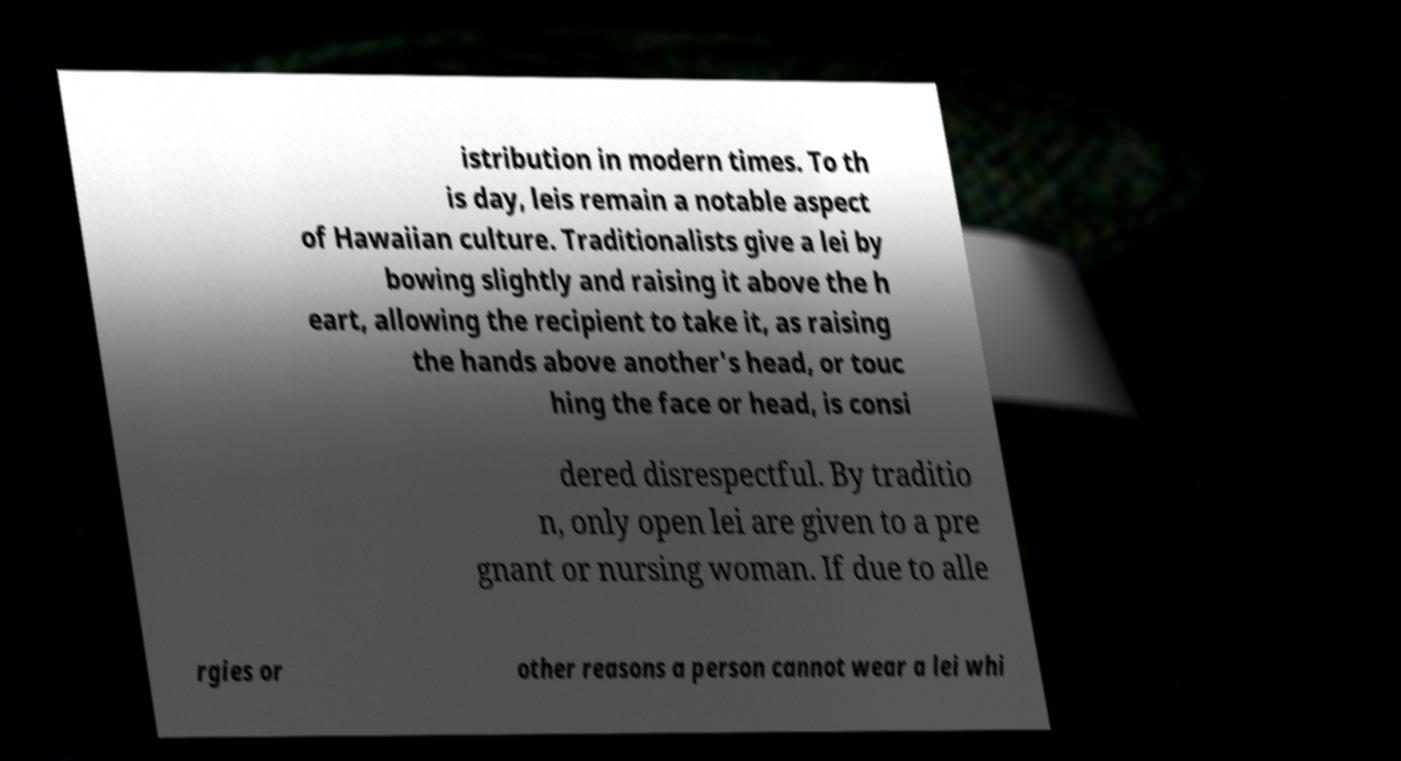There's text embedded in this image that I need extracted. Can you transcribe it verbatim? istribution in modern times. To th is day, leis remain a notable aspect of Hawaiian culture. Traditionalists give a lei by bowing slightly and raising it above the h eart, allowing the recipient to take it, as raising the hands above another's head, or touc hing the face or head, is consi dered disrespectful. By traditio n, only open lei are given to a pre gnant or nursing woman. If due to alle rgies or other reasons a person cannot wear a lei whi 